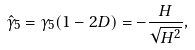Convert formula to latex. <formula><loc_0><loc_0><loc_500><loc_500>\hat { \gamma } _ { 5 } = \gamma _ { 5 } ( 1 - 2 D ) = - \frac { H } { \sqrt { H ^ { 2 } } } ,</formula> 